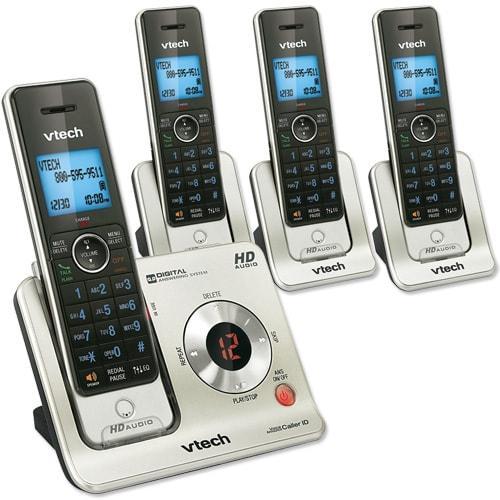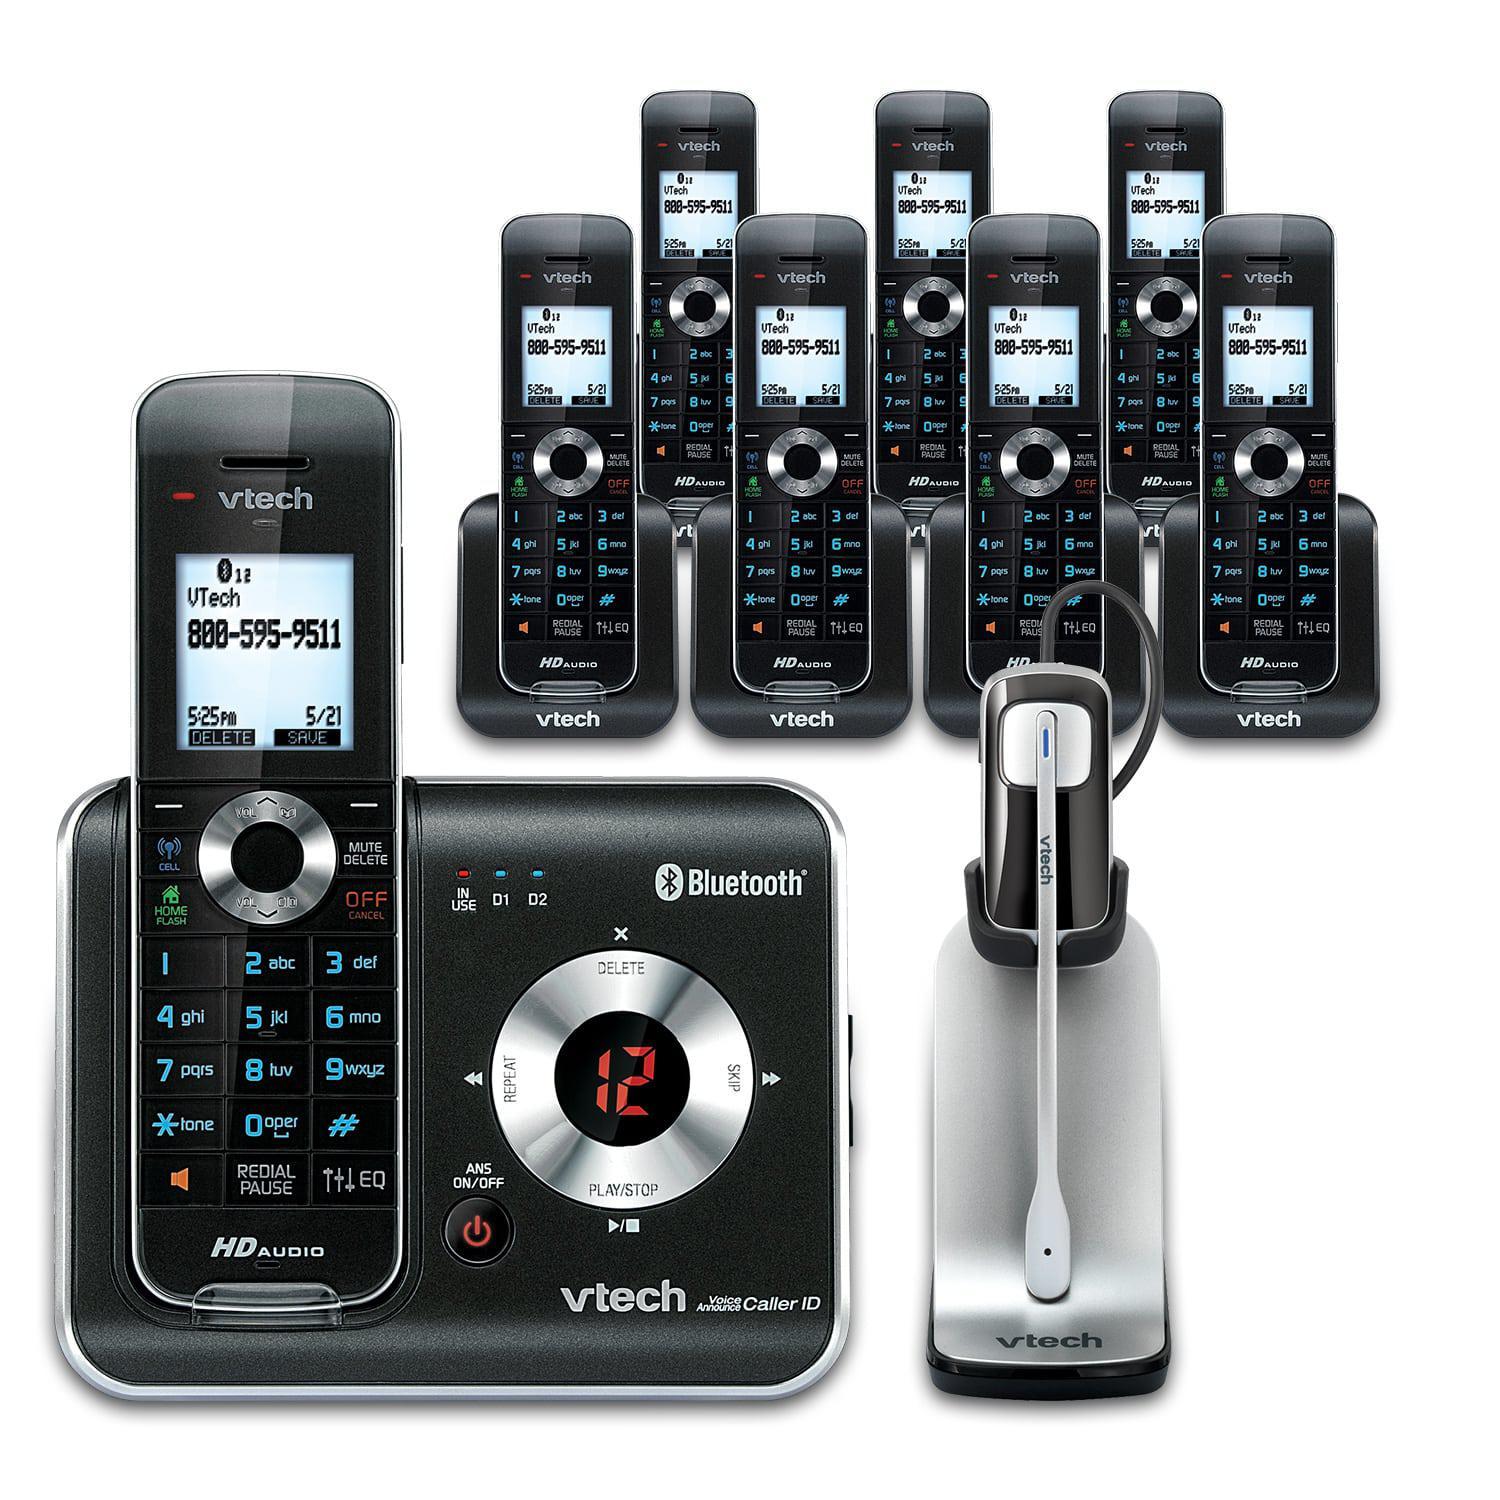The first image is the image on the left, the second image is the image on the right. For the images displayed, is the sentence "One of the images shows the side profile of a phone." factually correct? Answer yes or no. No. 